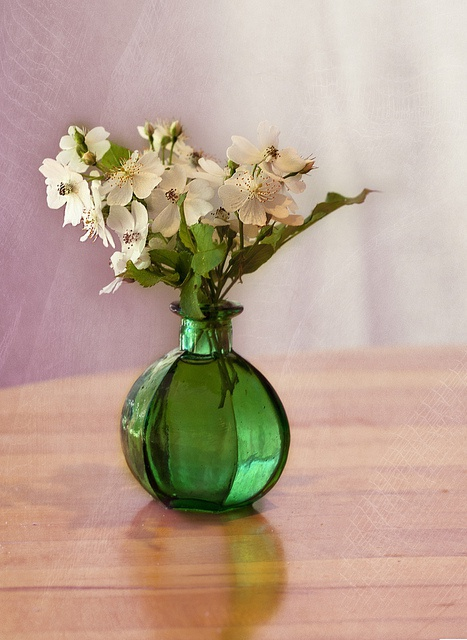Describe the objects in this image and their specific colors. I can see dining table in darkgray, tan, salmon, and olive tones and vase in darkgray, darkgreen, black, and green tones in this image. 